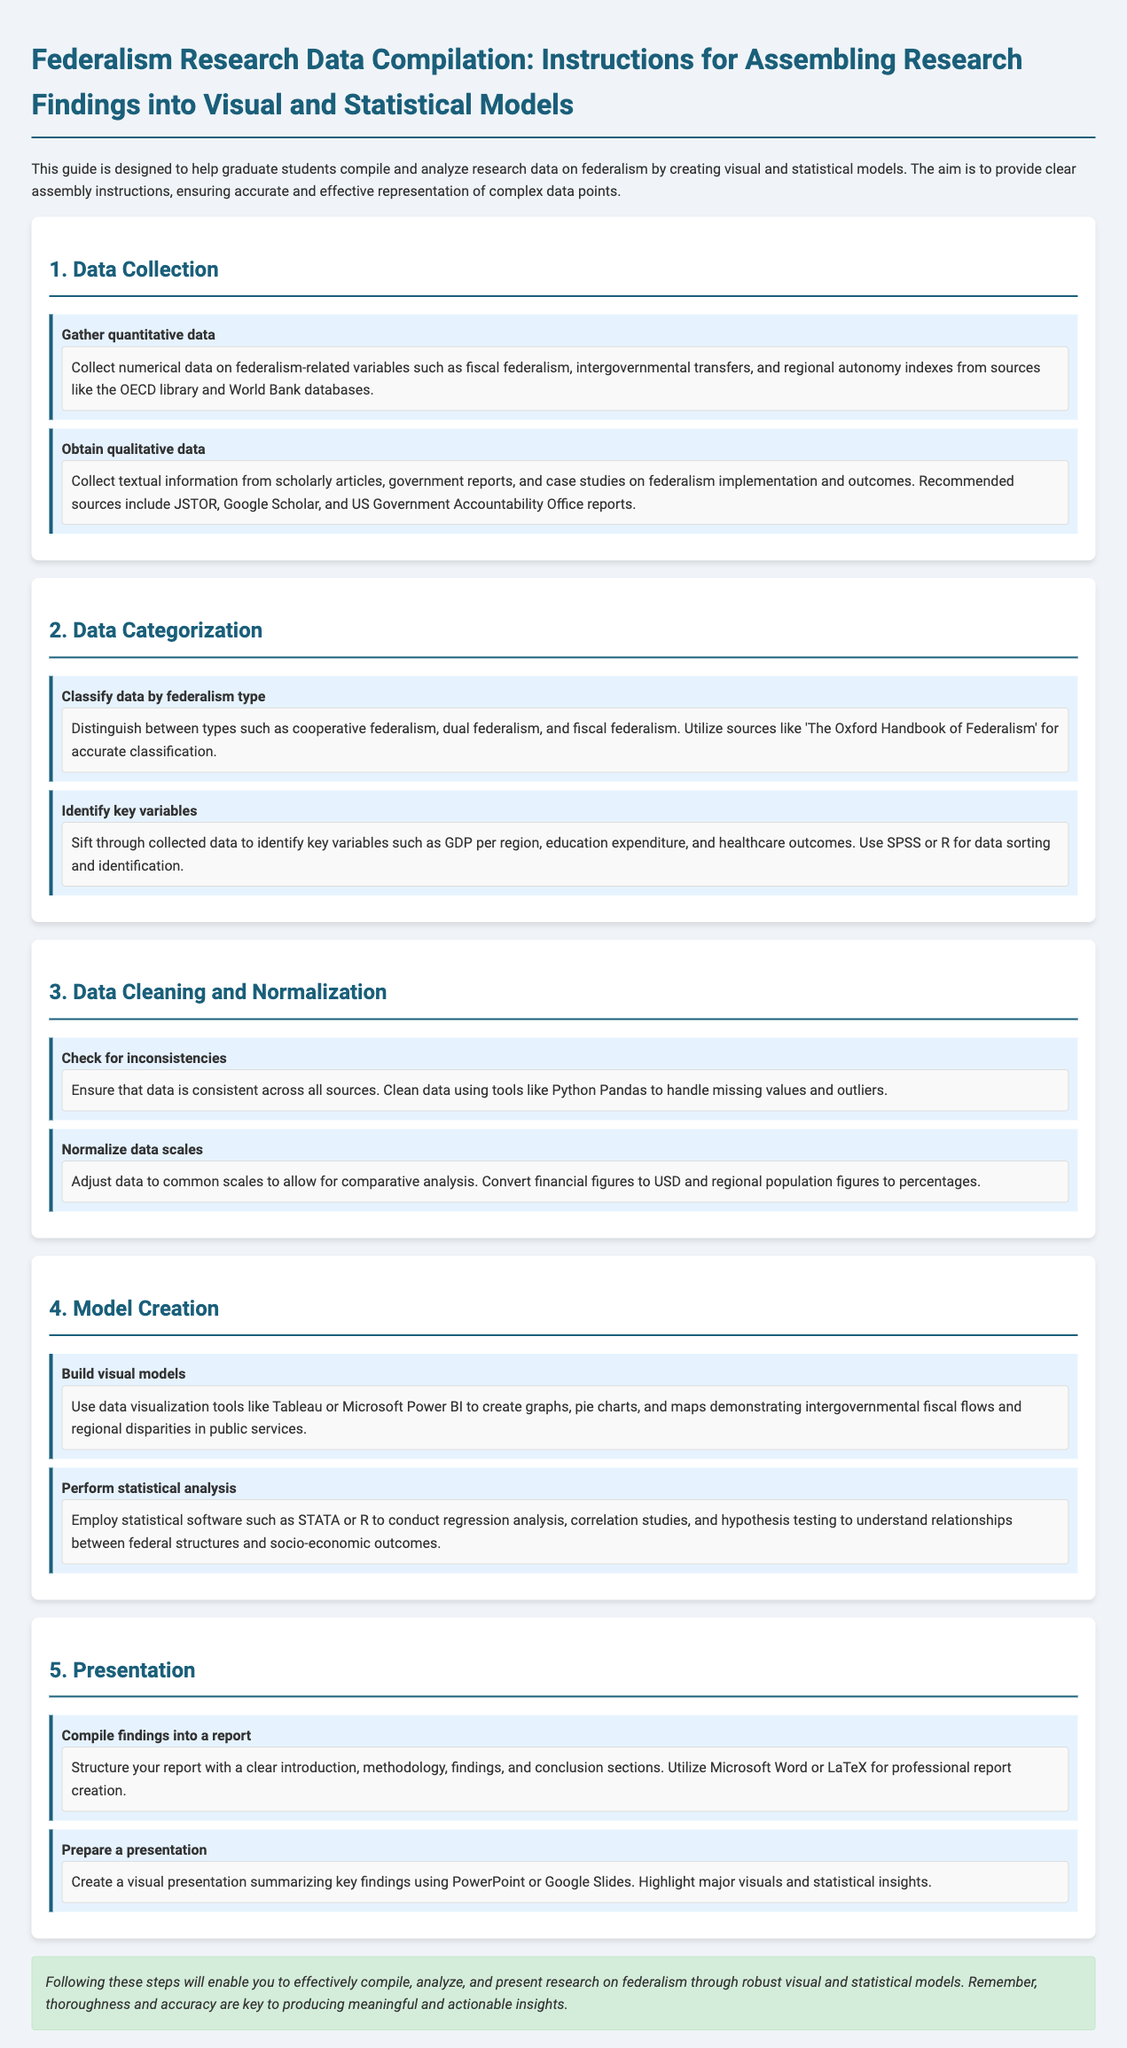What is the title of the document? The title is stated at the beginning of the document.
Answer: Federalism Research Data Compilation: Instructions for Assembling Research Findings into Visual and Statistical Models What source is recommended for gathering quantitative data? The document specifically mentions sources for collecting quantitative data.
Answer: OECD library and World Bank databases What are the two types of data collection mentioned? The document specifies two types of data collection involved in the research process.
Answer: Quantitative data and qualitative data Which statistical software is mentioned for performing analysis? The document lists specific software used for statistical analysis.
Answer: STATA or R What is the first step in the assembly process? The document outlines a specific order of steps to follow, starting with one particular step.
Answer: Data Collection What tool should be used for building visual models? The document recommends a specific type of tool for creating visual models.
Answer: Tableau or Microsoft Power BI What is the purpose of normalizing data scales? The document describes the reason behind adjusting data scales in the research process.
Answer: Allow for comparative analysis What should be included in the report structure? The document outlines essential components of the report structure.
Answer: Introduction, methodology, findings, and conclusion sections What is emphasized as key to producing insights? The document concludes with a specific emphasis on an important aspect of research.
Answer: Thoroughness and accuracy 